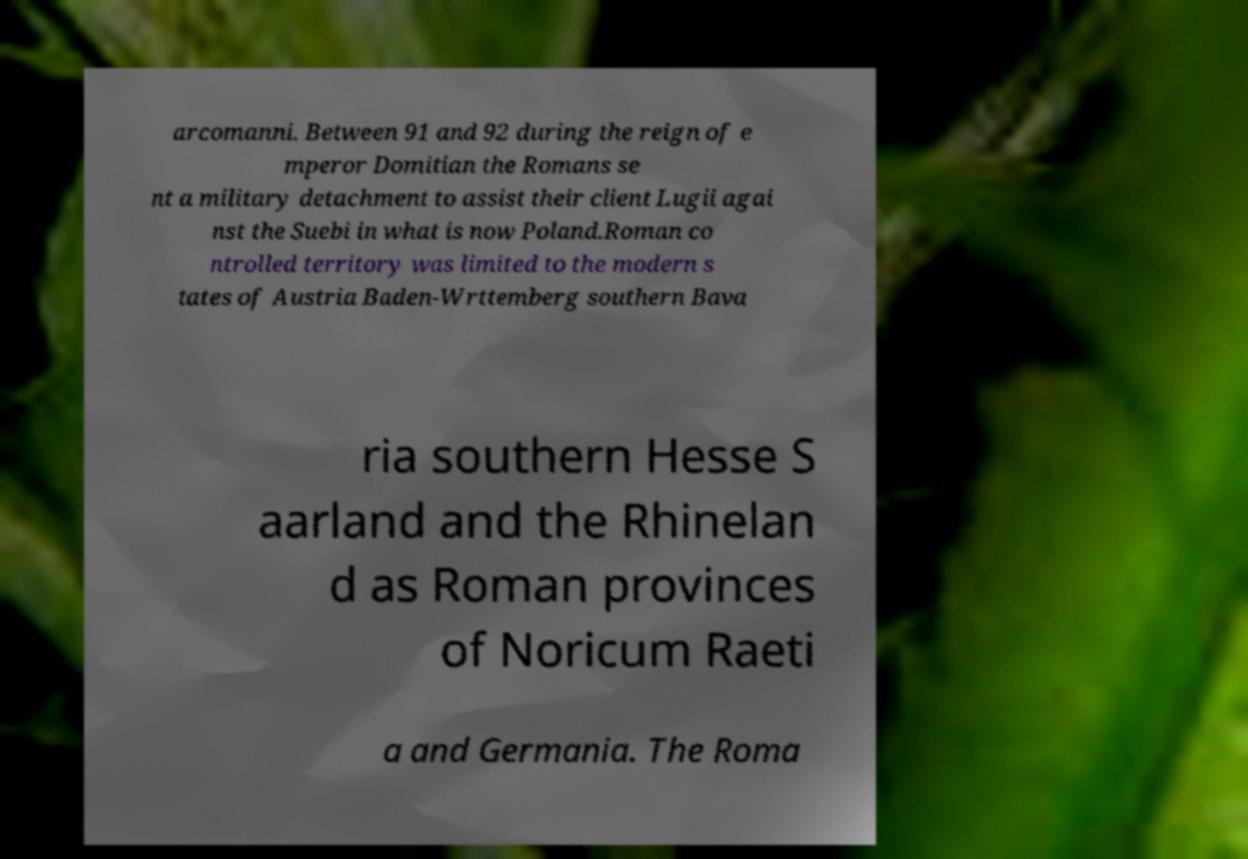Please identify and transcribe the text found in this image. arcomanni. Between 91 and 92 during the reign of e mperor Domitian the Romans se nt a military detachment to assist their client Lugii agai nst the Suebi in what is now Poland.Roman co ntrolled territory was limited to the modern s tates of Austria Baden-Wrttemberg southern Bava ria southern Hesse S aarland and the Rhinelan d as Roman provinces of Noricum Raeti a and Germania. The Roma 